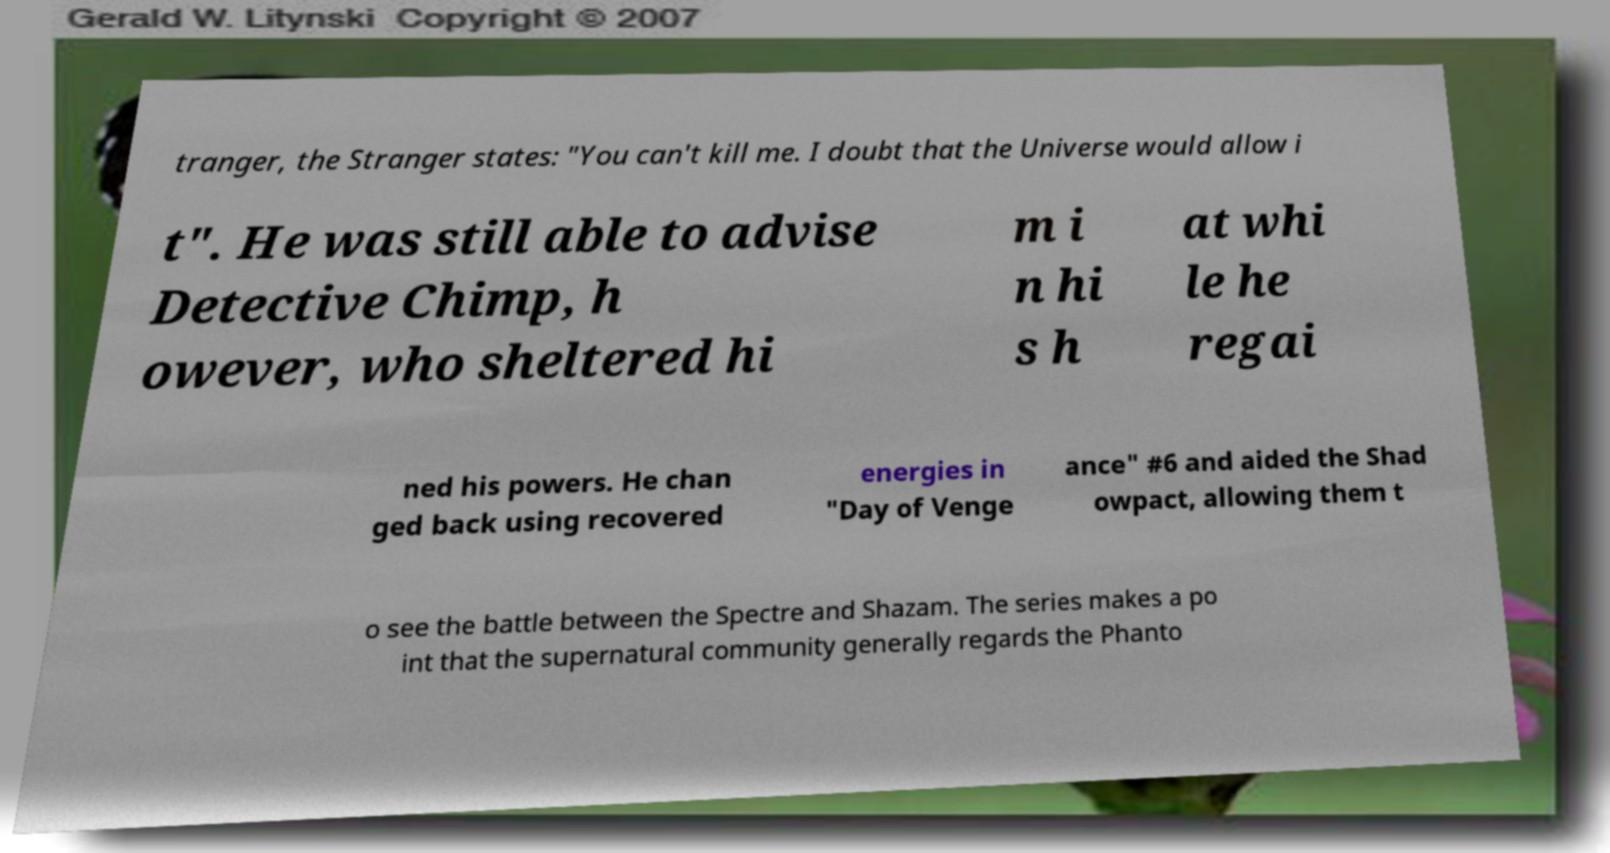Could you assist in decoding the text presented in this image and type it out clearly? tranger, the Stranger states: "You can't kill me. I doubt that the Universe would allow i t". He was still able to advise Detective Chimp, h owever, who sheltered hi m i n hi s h at whi le he regai ned his powers. He chan ged back using recovered energies in "Day of Venge ance" #6 and aided the Shad owpact, allowing them t o see the battle between the Spectre and Shazam. The series makes a po int that the supernatural community generally regards the Phanto 